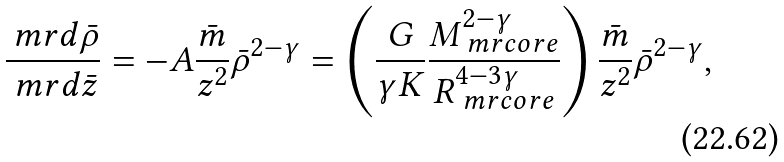<formula> <loc_0><loc_0><loc_500><loc_500>\frac { \ m r { d } \bar { \rho } } { \ m r { d } \bar { z } } = - A \frac { \bar { m } } { z ^ { 2 } } \bar { \rho } ^ { 2 - \gamma } = \left ( \frac { G } { \gamma K } \frac { M _ { \ m r { c o r e } } ^ { 2 - \gamma } } { R _ { \ m r { c o r e } } ^ { 4 - 3 \gamma } } \right ) \frac { \bar { m } } { z ^ { 2 } } \bar { \rho } ^ { 2 - \gamma } ,</formula> 